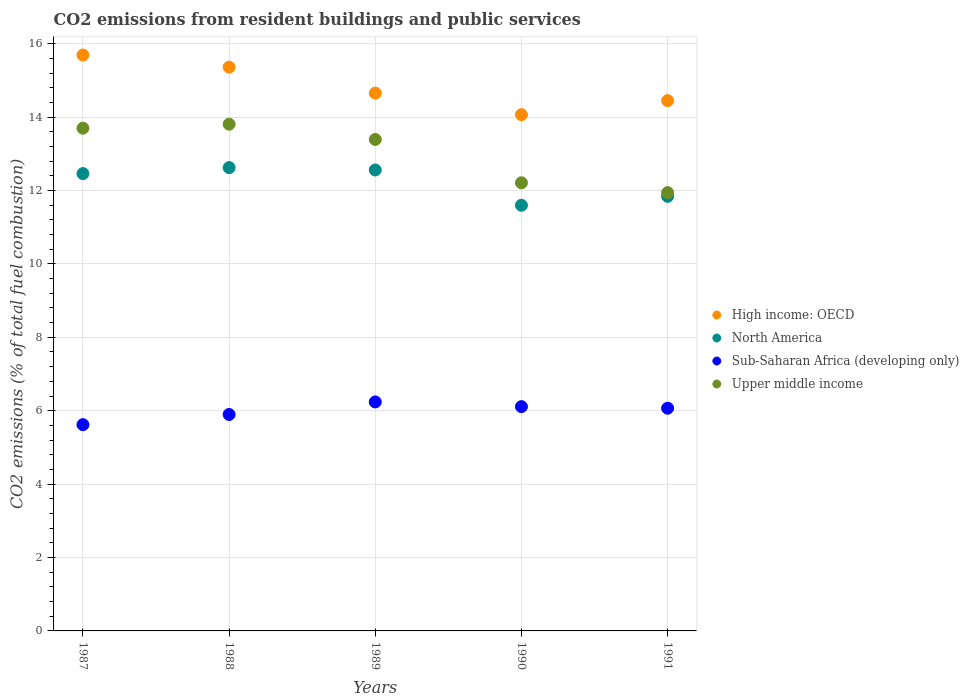What is the total CO2 emitted in North America in 1987?
Your answer should be very brief. 12.46. Across all years, what is the maximum total CO2 emitted in Sub-Saharan Africa (developing only)?
Your answer should be very brief. 6.24. Across all years, what is the minimum total CO2 emitted in High income: OECD?
Offer a very short reply. 14.06. What is the total total CO2 emitted in Sub-Saharan Africa (developing only) in the graph?
Make the answer very short. 29.93. What is the difference between the total CO2 emitted in North America in 1988 and that in 1989?
Keep it short and to the point. 0.06. What is the difference between the total CO2 emitted in Upper middle income in 1991 and the total CO2 emitted in High income: OECD in 1990?
Your answer should be compact. -2.12. What is the average total CO2 emitted in Upper middle income per year?
Give a very brief answer. 13.01. In the year 1991, what is the difference between the total CO2 emitted in Upper middle income and total CO2 emitted in North America?
Keep it short and to the point. 0.1. In how many years, is the total CO2 emitted in Sub-Saharan Africa (developing only) greater than 7.6?
Make the answer very short. 0. What is the ratio of the total CO2 emitted in High income: OECD in 1987 to that in 1988?
Make the answer very short. 1.02. Is the difference between the total CO2 emitted in Upper middle income in 1989 and 1991 greater than the difference between the total CO2 emitted in North America in 1989 and 1991?
Give a very brief answer. Yes. What is the difference between the highest and the second highest total CO2 emitted in North America?
Ensure brevity in your answer.  0.06. What is the difference between the highest and the lowest total CO2 emitted in High income: OECD?
Provide a short and direct response. 1.62. In how many years, is the total CO2 emitted in Sub-Saharan Africa (developing only) greater than the average total CO2 emitted in Sub-Saharan Africa (developing only) taken over all years?
Your answer should be very brief. 3. Is the sum of the total CO2 emitted in Upper middle income in 1988 and 1991 greater than the maximum total CO2 emitted in North America across all years?
Your answer should be compact. Yes. Is it the case that in every year, the sum of the total CO2 emitted in Sub-Saharan Africa (developing only) and total CO2 emitted in North America  is greater than the sum of total CO2 emitted in High income: OECD and total CO2 emitted in Upper middle income?
Keep it short and to the point. No. Is it the case that in every year, the sum of the total CO2 emitted in Upper middle income and total CO2 emitted in Sub-Saharan Africa (developing only)  is greater than the total CO2 emitted in North America?
Your response must be concise. Yes. Is the total CO2 emitted in Sub-Saharan Africa (developing only) strictly greater than the total CO2 emitted in High income: OECD over the years?
Keep it short and to the point. No. How many years are there in the graph?
Ensure brevity in your answer.  5. What is the difference between two consecutive major ticks on the Y-axis?
Offer a terse response. 2. Are the values on the major ticks of Y-axis written in scientific E-notation?
Your response must be concise. No. Does the graph contain grids?
Provide a succinct answer. Yes. Where does the legend appear in the graph?
Offer a very short reply. Center right. How many legend labels are there?
Ensure brevity in your answer.  4. How are the legend labels stacked?
Offer a terse response. Vertical. What is the title of the graph?
Offer a terse response. CO2 emissions from resident buildings and public services. Does "Paraguay" appear as one of the legend labels in the graph?
Your response must be concise. No. What is the label or title of the Y-axis?
Your answer should be compact. CO2 emissions (% of total fuel combustion). What is the CO2 emissions (% of total fuel combustion) in High income: OECD in 1987?
Provide a short and direct response. 15.69. What is the CO2 emissions (% of total fuel combustion) in North America in 1987?
Your response must be concise. 12.46. What is the CO2 emissions (% of total fuel combustion) of Sub-Saharan Africa (developing only) in 1987?
Make the answer very short. 5.62. What is the CO2 emissions (% of total fuel combustion) of Upper middle income in 1987?
Keep it short and to the point. 13.7. What is the CO2 emissions (% of total fuel combustion) in High income: OECD in 1988?
Offer a terse response. 15.36. What is the CO2 emissions (% of total fuel combustion) of North America in 1988?
Offer a terse response. 12.62. What is the CO2 emissions (% of total fuel combustion) in Sub-Saharan Africa (developing only) in 1988?
Keep it short and to the point. 5.9. What is the CO2 emissions (% of total fuel combustion) in Upper middle income in 1988?
Keep it short and to the point. 13.81. What is the CO2 emissions (% of total fuel combustion) in High income: OECD in 1989?
Provide a succinct answer. 14.65. What is the CO2 emissions (% of total fuel combustion) in North America in 1989?
Provide a succinct answer. 12.56. What is the CO2 emissions (% of total fuel combustion) in Sub-Saharan Africa (developing only) in 1989?
Make the answer very short. 6.24. What is the CO2 emissions (% of total fuel combustion) of Upper middle income in 1989?
Offer a terse response. 13.39. What is the CO2 emissions (% of total fuel combustion) in High income: OECD in 1990?
Provide a succinct answer. 14.06. What is the CO2 emissions (% of total fuel combustion) in North America in 1990?
Your response must be concise. 11.6. What is the CO2 emissions (% of total fuel combustion) in Sub-Saharan Africa (developing only) in 1990?
Offer a very short reply. 6.11. What is the CO2 emissions (% of total fuel combustion) in Upper middle income in 1990?
Your response must be concise. 12.21. What is the CO2 emissions (% of total fuel combustion) in High income: OECD in 1991?
Ensure brevity in your answer.  14.45. What is the CO2 emissions (% of total fuel combustion) of North America in 1991?
Provide a succinct answer. 11.84. What is the CO2 emissions (% of total fuel combustion) in Sub-Saharan Africa (developing only) in 1991?
Your answer should be compact. 6.07. What is the CO2 emissions (% of total fuel combustion) of Upper middle income in 1991?
Keep it short and to the point. 11.94. Across all years, what is the maximum CO2 emissions (% of total fuel combustion) of High income: OECD?
Offer a terse response. 15.69. Across all years, what is the maximum CO2 emissions (% of total fuel combustion) of North America?
Your response must be concise. 12.62. Across all years, what is the maximum CO2 emissions (% of total fuel combustion) of Sub-Saharan Africa (developing only)?
Offer a terse response. 6.24. Across all years, what is the maximum CO2 emissions (% of total fuel combustion) in Upper middle income?
Give a very brief answer. 13.81. Across all years, what is the minimum CO2 emissions (% of total fuel combustion) of High income: OECD?
Your answer should be compact. 14.06. Across all years, what is the minimum CO2 emissions (% of total fuel combustion) of North America?
Give a very brief answer. 11.6. Across all years, what is the minimum CO2 emissions (% of total fuel combustion) of Sub-Saharan Africa (developing only)?
Offer a very short reply. 5.62. Across all years, what is the minimum CO2 emissions (% of total fuel combustion) in Upper middle income?
Offer a very short reply. 11.94. What is the total CO2 emissions (% of total fuel combustion) in High income: OECD in the graph?
Keep it short and to the point. 74.22. What is the total CO2 emissions (% of total fuel combustion) of North America in the graph?
Give a very brief answer. 61.08. What is the total CO2 emissions (% of total fuel combustion) of Sub-Saharan Africa (developing only) in the graph?
Provide a short and direct response. 29.93. What is the total CO2 emissions (% of total fuel combustion) in Upper middle income in the graph?
Provide a succinct answer. 65.04. What is the difference between the CO2 emissions (% of total fuel combustion) of High income: OECD in 1987 and that in 1988?
Give a very brief answer. 0.33. What is the difference between the CO2 emissions (% of total fuel combustion) of North America in 1987 and that in 1988?
Make the answer very short. -0.16. What is the difference between the CO2 emissions (% of total fuel combustion) of Sub-Saharan Africa (developing only) in 1987 and that in 1988?
Give a very brief answer. -0.28. What is the difference between the CO2 emissions (% of total fuel combustion) in Upper middle income in 1987 and that in 1988?
Make the answer very short. -0.11. What is the difference between the CO2 emissions (% of total fuel combustion) in High income: OECD in 1987 and that in 1989?
Make the answer very short. 1.04. What is the difference between the CO2 emissions (% of total fuel combustion) in North America in 1987 and that in 1989?
Ensure brevity in your answer.  -0.1. What is the difference between the CO2 emissions (% of total fuel combustion) in Sub-Saharan Africa (developing only) in 1987 and that in 1989?
Ensure brevity in your answer.  -0.62. What is the difference between the CO2 emissions (% of total fuel combustion) of Upper middle income in 1987 and that in 1989?
Ensure brevity in your answer.  0.31. What is the difference between the CO2 emissions (% of total fuel combustion) in High income: OECD in 1987 and that in 1990?
Provide a succinct answer. 1.62. What is the difference between the CO2 emissions (% of total fuel combustion) in North America in 1987 and that in 1990?
Provide a short and direct response. 0.86. What is the difference between the CO2 emissions (% of total fuel combustion) of Sub-Saharan Africa (developing only) in 1987 and that in 1990?
Keep it short and to the point. -0.49. What is the difference between the CO2 emissions (% of total fuel combustion) of Upper middle income in 1987 and that in 1990?
Give a very brief answer. 1.49. What is the difference between the CO2 emissions (% of total fuel combustion) of High income: OECD in 1987 and that in 1991?
Offer a terse response. 1.24. What is the difference between the CO2 emissions (% of total fuel combustion) of North America in 1987 and that in 1991?
Your answer should be very brief. 0.62. What is the difference between the CO2 emissions (% of total fuel combustion) of Sub-Saharan Africa (developing only) in 1987 and that in 1991?
Make the answer very short. -0.45. What is the difference between the CO2 emissions (% of total fuel combustion) of Upper middle income in 1987 and that in 1991?
Ensure brevity in your answer.  1.76. What is the difference between the CO2 emissions (% of total fuel combustion) of High income: OECD in 1988 and that in 1989?
Your response must be concise. 0.71. What is the difference between the CO2 emissions (% of total fuel combustion) in North America in 1988 and that in 1989?
Offer a terse response. 0.06. What is the difference between the CO2 emissions (% of total fuel combustion) in Sub-Saharan Africa (developing only) in 1988 and that in 1989?
Offer a very short reply. -0.34. What is the difference between the CO2 emissions (% of total fuel combustion) in Upper middle income in 1988 and that in 1989?
Offer a terse response. 0.42. What is the difference between the CO2 emissions (% of total fuel combustion) in High income: OECD in 1988 and that in 1990?
Offer a terse response. 1.3. What is the difference between the CO2 emissions (% of total fuel combustion) in North America in 1988 and that in 1990?
Offer a very short reply. 1.03. What is the difference between the CO2 emissions (% of total fuel combustion) of Sub-Saharan Africa (developing only) in 1988 and that in 1990?
Your answer should be compact. -0.21. What is the difference between the CO2 emissions (% of total fuel combustion) in Upper middle income in 1988 and that in 1990?
Provide a succinct answer. 1.6. What is the difference between the CO2 emissions (% of total fuel combustion) in High income: OECD in 1988 and that in 1991?
Offer a terse response. 0.91. What is the difference between the CO2 emissions (% of total fuel combustion) of North America in 1988 and that in 1991?
Ensure brevity in your answer.  0.78. What is the difference between the CO2 emissions (% of total fuel combustion) in Sub-Saharan Africa (developing only) in 1988 and that in 1991?
Offer a very short reply. -0.17. What is the difference between the CO2 emissions (% of total fuel combustion) of Upper middle income in 1988 and that in 1991?
Provide a short and direct response. 1.86. What is the difference between the CO2 emissions (% of total fuel combustion) in High income: OECD in 1989 and that in 1990?
Ensure brevity in your answer.  0.59. What is the difference between the CO2 emissions (% of total fuel combustion) of North America in 1989 and that in 1990?
Provide a short and direct response. 0.96. What is the difference between the CO2 emissions (% of total fuel combustion) in Sub-Saharan Africa (developing only) in 1989 and that in 1990?
Keep it short and to the point. 0.13. What is the difference between the CO2 emissions (% of total fuel combustion) of Upper middle income in 1989 and that in 1990?
Provide a short and direct response. 1.18. What is the difference between the CO2 emissions (% of total fuel combustion) in High income: OECD in 1989 and that in 1991?
Your response must be concise. 0.2. What is the difference between the CO2 emissions (% of total fuel combustion) of North America in 1989 and that in 1991?
Provide a succinct answer. 0.72. What is the difference between the CO2 emissions (% of total fuel combustion) in Sub-Saharan Africa (developing only) in 1989 and that in 1991?
Provide a short and direct response. 0.17. What is the difference between the CO2 emissions (% of total fuel combustion) in Upper middle income in 1989 and that in 1991?
Your answer should be compact. 1.45. What is the difference between the CO2 emissions (% of total fuel combustion) in High income: OECD in 1990 and that in 1991?
Make the answer very short. -0.38. What is the difference between the CO2 emissions (% of total fuel combustion) of North America in 1990 and that in 1991?
Keep it short and to the point. -0.24. What is the difference between the CO2 emissions (% of total fuel combustion) in Sub-Saharan Africa (developing only) in 1990 and that in 1991?
Offer a terse response. 0.04. What is the difference between the CO2 emissions (% of total fuel combustion) in Upper middle income in 1990 and that in 1991?
Your answer should be compact. 0.27. What is the difference between the CO2 emissions (% of total fuel combustion) in High income: OECD in 1987 and the CO2 emissions (% of total fuel combustion) in North America in 1988?
Your answer should be compact. 3.07. What is the difference between the CO2 emissions (% of total fuel combustion) in High income: OECD in 1987 and the CO2 emissions (% of total fuel combustion) in Sub-Saharan Africa (developing only) in 1988?
Make the answer very short. 9.79. What is the difference between the CO2 emissions (% of total fuel combustion) of High income: OECD in 1987 and the CO2 emissions (% of total fuel combustion) of Upper middle income in 1988?
Your answer should be very brief. 1.88. What is the difference between the CO2 emissions (% of total fuel combustion) of North America in 1987 and the CO2 emissions (% of total fuel combustion) of Sub-Saharan Africa (developing only) in 1988?
Provide a succinct answer. 6.56. What is the difference between the CO2 emissions (% of total fuel combustion) in North America in 1987 and the CO2 emissions (% of total fuel combustion) in Upper middle income in 1988?
Offer a terse response. -1.35. What is the difference between the CO2 emissions (% of total fuel combustion) in Sub-Saharan Africa (developing only) in 1987 and the CO2 emissions (% of total fuel combustion) in Upper middle income in 1988?
Provide a short and direct response. -8.19. What is the difference between the CO2 emissions (% of total fuel combustion) in High income: OECD in 1987 and the CO2 emissions (% of total fuel combustion) in North America in 1989?
Make the answer very short. 3.13. What is the difference between the CO2 emissions (% of total fuel combustion) of High income: OECD in 1987 and the CO2 emissions (% of total fuel combustion) of Sub-Saharan Africa (developing only) in 1989?
Provide a succinct answer. 9.45. What is the difference between the CO2 emissions (% of total fuel combustion) in High income: OECD in 1987 and the CO2 emissions (% of total fuel combustion) in Upper middle income in 1989?
Keep it short and to the point. 2.3. What is the difference between the CO2 emissions (% of total fuel combustion) in North America in 1987 and the CO2 emissions (% of total fuel combustion) in Sub-Saharan Africa (developing only) in 1989?
Give a very brief answer. 6.22. What is the difference between the CO2 emissions (% of total fuel combustion) in North America in 1987 and the CO2 emissions (% of total fuel combustion) in Upper middle income in 1989?
Your response must be concise. -0.93. What is the difference between the CO2 emissions (% of total fuel combustion) in Sub-Saharan Africa (developing only) in 1987 and the CO2 emissions (% of total fuel combustion) in Upper middle income in 1989?
Give a very brief answer. -7.77. What is the difference between the CO2 emissions (% of total fuel combustion) of High income: OECD in 1987 and the CO2 emissions (% of total fuel combustion) of North America in 1990?
Make the answer very short. 4.09. What is the difference between the CO2 emissions (% of total fuel combustion) of High income: OECD in 1987 and the CO2 emissions (% of total fuel combustion) of Sub-Saharan Africa (developing only) in 1990?
Ensure brevity in your answer.  9.58. What is the difference between the CO2 emissions (% of total fuel combustion) of High income: OECD in 1987 and the CO2 emissions (% of total fuel combustion) of Upper middle income in 1990?
Make the answer very short. 3.48. What is the difference between the CO2 emissions (% of total fuel combustion) of North America in 1987 and the CO2 emissions (% of total fuel combustion) of Sub-Saharan Africa (developing only) in 1990?
Your answer should be very brief. 6.35. What is the difference between the CO2 emissions (% of total fuel combustion) in North America in 1987 and the CO2 emissions (% of total fuel combustion) in Upper middle income in 1990?
Offer a terse response. 0.25. What is the difference between the CO2 emissions (% of total fuel combustion) of Sub-Saharan Africa (developing only) in 1987 and the CO2 emissions (% of total fuel combustion) of Upper middle income in 1990?
Offer a very short reply. -6.59. What is the difference between the CO2 emissions (% of total fuel combustion) in High income: OECD in 1987 and the CO2 emissions (% of total fuel combustion) in North America in 1991?
Provide a succinct answer. 3.85. What is the difference between the CO2 emissions (% of total fuel combustion) in High income: OECD in 1987 and the CO2 emissions (% of total fuel combustion) in Sub-Saharan Africa (developing only) in 1991?
Offer a terse response. 9.62. What is the difference between the CO2 emissions (% of total fuel combustion) in High income: OECD in 1987 and the CO2 emissions (% of total fuel combustion) in Upper middle income in 1991?
Ensure brevity in your answer.  3.75. What is the difference between the CO2 emissions (% of total fuel combustion) in North America in 1987 and the CO2 emissions (% of total fuel combustion) in Sub-Saharan Africa (developing only) in 1991?
Offer a terse response. 6.39. What is the difference between the CO2 emissions (% of total fuel combustion) of North America in 1987 and the CO2 emissions (% of total fuel combustion) of Upper middle income in 1991?
Provide a short and direct response. 0.52. What is the difference between the CO2 emissions (% of total fuel combustion) of Sub-Saharan Africa (developing only) in 1987 and the CO2 emissions (% of total fuel combustion) of Upper middle income in 1991?
Provide a short and direct response. -6.32. What is the difference between the CO2 emissions (% of total fuel combustion) of High income: OECD in 1988 and the CO2 emissions (% of total fuel combustion) of North America in 1989?
Provide a succinct answer. 2.8. What is the difference between the CO2 emissions (% of total fuel combustion) in High income: OECD in 1988 and the CO2 emissions (% of total fuel combustion) in Sub-Saharan Africa (developing only) in 1989?
Your answer should be compact. 9.12. What is the difference between the CO2 emissions (% of total fuel combustion) of High income: OECD in 1988 and the CO2 emissions (% of total fuel combustion) of Upper middle income in 1989?
Give a very brief answer. 1.97. What is the difference between the CO2 emissions (% of total fuel combustion) in North America in 1988 and the CO2 emissions (% of total fuel combustion) in Sub-Saharan Africa (developing only) in 1989?
Offer a very short reply. 6.38. What is the difference between the CO2 emissions (% of total fuel combustion) in North America in 1988 and the CO2 emissions (% of total fuel combustion) in Upper middle income in 1989?
Keep it short and to the point. -0.77. What is the difference between the CO2 emissions (% of total fuel combustion) in Sub-Saharan Africa (developing only) in 1988 and the CO2 emissions (% of total fuel combustion) in Upper middle income in 1989?
Offer a terse response. -7.49. What is the difference between the CO2 emissions (% of total fuel combustion) of High income: OECD in 1988 and the CO2 emissions (% of total fuel combustion) of North America in 1990?
Offer a terse response. 3.76. What is the difference between the CO2 emissions (% of total fuel combustion) of High income: OECD in 1988 and the CO2 emissions (% of total fuel combustion) of Sub-Saharan Africa (developing only) in 1990?
Your response must be concise. 9.25. What is the difference between the CO2 emissions (% of total fuel combustion) of High income: OECD in 1988 and the CO2 emissions (% of total fuel combustion) of Upper middle income in 1990?
Make the answer very short. 3.15. What is the difference between the CO2 emissions (% of total fuel combustion) in North America in 1988 and the CO2 emissions (% of total fuel combustion) in Sub-Saharan Africa (developing only) in 1990?
Your response must be concise. 6.51. What is the difference between the CO2 emissions (% of total fuel combustion) in North America in 1988 and the CO2 emissions (% of total fuel combustion) in Upper middle income in 1990?
Your answer should be very brief. 0.41. What is the difference between the CO2 emissions (% of total fuel combustion) in Sub-Saharan Africa (developing only) in 1988 and the CO2 emissions (% of total fuel combustion) in Upper middle income in 1990?
Keep it short and to the point. -6.31. What is the difference between the CO2 emissions (% of total fuel combustion) in High income: OECD in 1988 and the CO2 emissions (% of total fuel combustion) in North America in 1991?
Offer a terse response. 3.52. What is the difference between the CO2 emissions (% of total fuel combustion) of High income: OECD in 1988 and the CO2 emissions (% of total fuel combustion) of Sub-Saharan Africa (developing only) in 1991?
Give a very brief answer. 9.29. What is the difference between the CO2 emissions (% of total fuel combustion) in High income: OECD in 1988 and the CO2 emissions (% of total fuel combustion) in Upper middle income in 1991?
Offer a very short reply. 3.42. What is the difference between the CO2 emissions (% of total fuel combustion) in North America in 1988 and the CO2 emissions (% of total fuel combustion) in Sub-Saharan Africa (developing only) in 1991?
Provide a short and direct response. 6.56. What is the difference between the CO2 emissions (% of total fuel combustion) in North America in 1988 and the CO2 emissions (% of total fuel combustion) in Upper middle income in 1991?
Your answer should be very brief. 0.68. What is the difference between the CO2 emissions (% of total fuel combustion) of Sub-Saharan Africa (developing only) in 1988 and the CO2 emissions (% of total fuel combustion) of Upper middle income in 1991?
Offer a terse response. -6.04. What is the difference between the CO2 emissions (% of total fuel combustion) in High income: OECD in 1989 and the CO2 emissions (% of total fuel combustion) in North America in 1990?
Make the answer very short. 3.06. What is the difference between the CO2 emissions (% of total fuel combustion) of High income: OECD in 1989 and the CO2 emissions (% of total fuel combustion) of Sub-Saharan Africa (developing only) in 1990?
Provide a succinct answer. 8.54. What is the difference between the CO2 emissions (% of total fuel combustion) of High income: OECD in 1989 and the CO2 emissions (% of total fuel combustion) of Upper middle income in 1990?
Ensure brevity in your answer.  2.44. What is the difference between the CO2 emissions (% of total fuel combustion) of North America in 1989 and the CO2 emissions (% of total fuel combustion) of Sub-Saharan Africa (developing only) in 1990?
Your answer should be very brief. 6.45. What is the difference between the CO2 emissions (% of total fuel combustion) in North America in 1989 and the CO2 emissions (% of total fuel combustion) in Upper middle income in 1990?
Keep it short and to the point. 0.35. What is the difference between the CO2 emissions (% of total fuel combustion) in Sub-Saharan Africa (developing only) in 1989 and the CO2 emissions (% of total fuel combustion) in Upper middle income in 1990?
Your response must be concise. -5.97. What is the difference between the CO2 emissions (% of total fuel combustion) in High income: OECD in 1989 and the CO2 emissions (% of total fuel combustion) in North America in 1991?
Keep it short and to the point. 2.81. What is the difference between the CO2 emissions (% of total fuel combustion) in High income: OECD in 1989 and the CO2 emissions (% of total fuel combustion) in Sub-Saharan Africa (developing only) in 1991?
Your answer should be very brief. 8.59. What is the difference between the CO2 emissions (% of total fuel combustion) of High income: OECD in 1989 and the CO2 emissions (% of total fuel combustion) of Upper middle income in 1991?
Provide a short and direct response. 2.71. What is the difference between the CO2 emissions (% of total fuel combustion) in North America in 1989 and the CO2 emissions (% of total fuel combustion) in Sub-Saharan Africa (developing only) in 1991?
Offer a terse response. 6.49. What is the difference between the CO2 emissions (% of total fuel combustion) in North America in 1989 and the CO2 emissions (% of total fuel combustion) in Upper middle income in 1991?
Your response must be concise. 0.62. What is the difference between the CO2 emissions (% of total fuel combustion) in Sub-Saharan Africa (developing only) in 1989 and the CO2 emissions (% of total fuel combustion) in Upper middle income in 1991?
Your answer should be compact. -5.7. What is the difference between the CO2 emissions (% of total fuel combustion) of High income: OECD in 1990 and the CO2 emissions (% of total fuel combustion) of North America in 1991?
Keep it short and to the point. 2.22. What is the difference between the CO2 emissions (% of total fuel combustion) in High income: OECD in 1990 and the CO2 emissions (% of total fuel combustion) in Sub-Saharan Africa (developing only) in 1991?
Make the answer very short. 8. What is the difference between the CO2 emissions (% of total fuel combustion) of High income: OECD in 1990 and the CO2 emissions (% of total fuel combustion) of Upper middle income in 1991?
Offer a terse response. 2.12. What is the difference between the CO2 emissions (% of total fuel combustion) in North America in 1990 and the CO2 emissions (% of total fuel combustion) in Sub-Saharan Africa (developing only) in 1991?
Your answer should be compact. 5.53. What is the difference between the CO2 emissions (% of total fuel combustion) in North America in 1990 and the CO2 emissions (% of total fuel combustion) in Upper middle income in 1991?
Ensure brevity in your answer.  -0.34. What is the difference between the CO2 emissions (% of total fuel combustion) of Sub-Saharan Africa (developing only) in 1990 and the CO2 emissions (% of total fuel combustion) of Upper middle income in 1991?
Make the answer very short. -5.83. What is the average CO2 emissions (% of total fuel combustion) in High income: OECD per year?
Your response must be concise. 14.84. What is the average CO2 emissions (% of total fuel combustion) in North America per year?
Give a very brief answer. 12.22. What is the average CO2 emissions (% of total fuel combustion) of Sub-Saharan Africa (developing only) per year?
Your answer should be compact. 5.99. What is the average CO2 emissions (% of total fuel combustion) of Upper middle income per year?
Ensure brevity in your answer.  13.01. In the year 1987, what is the difference between the CO2 emissions (% of total fuel combustion) in High income: OECD and CO2 emissions (% of total fuel combustion) in North America?
Provide a succinct answer. 3.23. In the year 1987, what is the difference between the CO2 emissions (% of total fuel combustion) in High income: OECD and CO2 emissions (% of total fuel combustion) in Sub-Saharan Africa (developing only)?
Make the answer very short. 10.07. In the year 1987, what is the difference between the CO2 emissions (% of total fuel combustion) in High income: OECD and CO2 emissions (% of total fuel combustion) in Upper middle income?
Keep it short and to the point. 1.99. In the year 1987, what is the difference between the CO2 emissions (% of total fuel combustion) of North America and CO2 emissions (% of total fuel combustion) of Sub-Saharan Africa (developing only)?
Provide a succinct answer. 6.84. In the year 1987, what is the difference between the CO2 emissions (% of total fuel combustion) of North America and CO2 emissions (% of total fuel combustion) of Upper middle income?
Provide a succinct answer. -1.24. In the year 1987, what is the difference between the CO2 emissions (% of total fuel combustion) of Sub-Saharan Africa (developing only) and CO2 emissions (% of total fuel combustion) of Upper middle income?
Provide a succinct answer. -8.08. In the year 1988, what is the difference between the CO2 emissions (% of total fuel combustion) of High income: OECD and CO2 emissions (% of total fuel combustion) of North America?
Your response must be concise. 2.74. In the year 1988, what is the difference between the CO2 emissions (% of total fuel combustion) of High income: OECD and CO2 emissions (% of total fuel combustion) of Sub-Saharan Africa (developing only)?
Keep it short and to the point. 9.46. In the year 1988, what is the difference between the CO2 emissions (% of total fuel combustion) of High income: OECD and CO2 emissions (% of total fuel combustion) of Upper middle income?
Your response must be concise. 1.55. In the year 1988, what is the difference between the CO2 emissions (% of total fuel combustion) of North America and CO2 emissions (% of total fuel combustion) of Sub-Saharan Africa (developing only)?
Give a very brief answer. 6.73. In the year 1988, what is the difference between the CO2 emissions (% of total fuel combustion) of North America and CO2 emissions (% of total fuel combustion) of Upper middle income?
Provide a succinct answer. -1.18. In the year 1988, what is the difference between the CO2 emissions (% of total fuel combustion) of Sub-Saharan Africa (developing only) and CO2 emissions (% of total fuel combustion) of Upper middle income?
Offer a very short reply. -7.91. In the year 1989, what is the difference between the CO2 emissions (% of total fuel combustion) of High income: OECD and CO2 emissions (% of total fuel combustion) of North America?
Keep it short and to the point. 2.09. In the year 1989, what is the difference between the CO2 emissions (% of total fuel combustion) in High income: OECD and CO2 emissions (% of total fuel combustion) in Sub-Saharan Africa (developing only)?
Keep it short and to the point. 8.41. In the year 1989, what is the difference between the CO2 emissions (% of total fuel combustion) of High income: OECD and CO2 emissions (% of total fuel combustion) of Upper middle income?
Ensure brevity in your answer.  1.26. In the year 1989, what is the difference between the CO2 emissions (% of total fuel combustion) of North America and CO2 emissions (% of total fuel combustion) of Sub-Saharan Africa (developing only)?
Make the answer very short. 6.32. In the year 1989, what is the difference between the CO2 emissions (% of total fuel combustion) of North America and CO2 emissions (% of total fuel combustion) of Upper middle income?
Ensure brevity in your answer.  -0.83. In the year 1989, what is the difference between the CO2 emissions (% of total fuel combustion) of Sub-Saharan Africa (developing only) and CO2 emissions (% of total fuel combustion) of Upper middle income?
Provide a short and direct response. -7.15. In the year 1990, what is the difference between the CO2 emissions (% of total fuel combustion) in High income: OECD and CO2 emissions (% of total fuel combustion) in North America?
Provide a succinct answer. 2.47. In the year 1990, what is the difference between the CO2 emissions (% of total fuel combustion) in High income: OECD and CO2 emissions (% of total fuel combustion) in Sub-Saharan Africa (developing only)?
Provide a succinct answer. 7.95. In the year 1990, what is the difference between the CO2 emissions (% of total fuel combustion) of High income: OECD and CO2 emissions (% of total fuel combustion) of Upper middle income?
Provide a succinct answer. 1.86. In the year 1990, what is the difference between the CO2 emissions (% of total fuel combustion) of North America and CO2 emissions (% of total fuel combustion) of Sub-Saharan Africa (developing only)?
Provide a succinct answer. 5.49. In the year 1990, what is the difference between the CO2 emissions (% of total fuel combustion) in North America and CO2 emissions (% of total fuel combustion) in Upper middle income?
Ensure brevity in your answer.  -0.61. In the year 1990, what is the difference between the CO2 emissions (% of total fuel combustion) in Sub-Saharan Africa (developing only) and CO2 emissions (% of total fuel combustion) in Upper middle income?
Keep it short and to the point. -6.1. In the year 1991, what is the difference between the CO2 emissions (% of total fuel combustion) of High income: OECD and CO2 emissions (% of total fuel combustion) of North America?
Your answer should be very brief. 2.61. In the year 1991, what is the difference between the CO2 emissions (% of total fuel combustion) in High income: OECD and CO2 emissions (% of total fuel combustion) in Sub-Saharan Africa (developing only)?
Keep it short and to the point. 8.38. In the year 1991, what is the difference between the CO2 emissions (% of total fuel combustion) of High income: OECD and CO2 emissions (% of total fuel combustion) of Upper middle income?
Provide a succinct answer. 2.51. In the year 1991, what is the difference between the CO2 emissions (% of total fuel combustion) of North America and CO2 emissions (% of total fuel combustion) of Sub-Saharan Africa (developing only)?
Give a very brief answer. 5.77. In the year 1991, what is the difference between the CO2 emissions (% of total fuel combustion) of North America and CO2 emissions (% of total fuel combustion) of Upper middle income?
Provide a succinct answer. -0.1. In the year 1991, what is the difference between the CO2 emissions (% of total fuel combustion) in Sub-Saharan Africa (developing only) and CO2 emissions (% of total fuel combustion) in Upper middle income?
Make the answer very short. -5.87. What is the ratio of the CO2 emissions (% of total fuel combustion) of High income: OECD in 1987 to that in 1988?
Offer a terse response. 1.02. What is the ratio of the CO2 emissions (% of total fuel combustion) in North America in 1987 to that in 1988?
Keep it short and to the point. 0.99. What is the ratio of the CO2 emissions (% of total fuel combustion) in Sub-Saharan Africa (developing only) in 1987 to that in 1988?
Your answer should be very brief. 0.95. What is the ratio of the CO2 emissions (% of total fuel combustion) of High income: OECD in 1987 to that in 1989?
Ensure brevity in your answer.  1.07. What is the ratio of the CO2 emissions (% of total fuel combustion) of Sub-Saharan Africa (developing only) in 1987 to that in 1989?
Your answer should be compact. 0.9. What is the ratio of the CO2 emissions (% of total fuel combustion) of Upper middle income in 1987 to that in 1989?
Your answer should be compact. 1.02. What is the ratio of the CO2 emissions (% of total fuel combustion) of High income: OECD in 1987 to that in 1990?
Keep it short and to the point. 1.12. What is the ratio of the CO2 emissions (% of total fuel combustion) of North America in 1987 to that in 1990?
Keep it short and to the point. 1.07. What is the ratio of the CO2 emissions (% of total fuel combustion) of Sub-Saharan Africa (developing only) in 1987 to that in 1990?
Give a very brief answer. 0.92. What is the ratio of the CO2 emissions (% of total fuel combustion) of Upper middle income in 1987 to that in 1990?
Give a very brief answer. 1.12. What is the ratio of the CO2 emissions (% of total fuel combustion) of High income: OECD in 1987 to that in 1991?
Offer a terse response. 1.09. What is the ratio of the CO2 emissions (% of total fuel combustion) in North America in 1987 to that in 1991?
Your answer should be compact. 1.05. What is the ratio of the CO2 emissions (% of total fuel combustion) of Sub-Saharan Africa (developing only) in 1987 to that in 1991?
Provide a short and direct response. 0.93. What is the ratio of the CO2 emissions (% of total fuel combustion) in Upper middle income in 1987 to that in 1991?
Make the answer very short. 1.15. What is the ratio of the CO2 emissions (% of total fuel combustion) of High income: OECD in 1988 to that in 1989?
Keep it short and to the point. 1.05. What is the ratio of the CO2 emissions (% of total fuel combustion) of Sub-Saharan Africa (developing only) in 1988 to that in 1989?
Give a very brief answer. 0.95. What is the ratio of the CO2 emissions (% of total fuel combustion) in Upper middle income in 1988 to that in 1989?
Ensure brevity in your answer.  1.03. What is the ratio of the CO2 emissions (% of total fuel combustion) in High income: OECD in 1988 to that in 1990?
Offer a terse response. 1.09. What is the ratio of the CO2 emissions (% of total fuel combustion) in North America in 1988 to that in 1990?
Your answer should be compact. 1.09. What is the ratio of the CO2 emissions (% of total fuel combustion) of Sub-Saharan Africa (developing only) in 1988 to that in 1990?
Give a very brief answer. 0.96. What is the ratio of the CO2 emissions (% of total fuel combustion) of Upper middle income in 1988 to that in 1990?
Give a very brief answer. 1.13. What is the ratio of the CO2 emissions (% of total fuel combustion) of High income: OECD in 1988 to that in 1991?
Provide a short and direct response. 1.06. What is the ratio of the CO2 emissions (% of total fuel combustion) of North America in 1988 to that in 1991?
Give a very brief answer. 1.07. What is the ratio of the CO2 emissions (% of total fuel combustion) of Sub-Saharan Africa (developing only) in 1988 to that in 1991?
Provide a succinct answer. 0.97. What is the ratio of the CO2 emissions (% of total fuel combustion) of Upper middle income in 1988 to that in 1991?
Offer a very short reply. 1.16. What is the ratio of the CO2 emissions (% of total fuel combustion) in High income: OECD in 1989 to that in 1990?
Your answer should be compact. 1.04. What is the ratio of the CO2 emissions (% of total fuel combustion) in North America in 1989 to that in 1990?
Offer a very short reply. 1.08. What is the ratio of the CO2 emissions (% of total fuel combustion) in Sub-Saharan Africa (developing only) in 1989 to that in 1990?
Your response must be concise. 1.02. What is the ratio of the CO2 emissions (% of total fuel combustion) of Upper middle income in 1989 to that in 1990?
Your answer should be very brief. 1.1. What is the ratio of the CO2 emissions (% of total fuel combustion) of High income: OECD in 1989 to that in 1991?
Ensure brevity in your answer.  1.01. What is the ratio of the CO2 emissions (% of total fuel combustion) of North America in 1989 to that in 1991?
Your response must be concise. 1.06. What is the ratio of the CO2 emissions (% of total fuel combustion) in Sub-Saharan Africa (developing only) in 1989 to that in 1991?
Keep it short and to the point. 1.03. What is the ratio of the CO2 emissions (% of total fuel combustion) of Upper middle income in 1989 to that in 1991?
Ensure brevity in your answer.  1.12. What is the ratio of the CO2 emissions (% of total fuel combustion) in High income: OECD in 1990 to that in 1991?
Give a very brief answer. 0.97. What is the ratio of the CO2 emissions (% of total fuel combustion) of North America in 1990 to that in 1991?
Ensure brevity in your answer.  0.98. What is the ratio of the CO2 emissions (% of total fuel combustion) in Sub-Saharan Africa (developing only) in 1990 to that in 1991?
Offer a terse response. 1.01. What is the ratio of the CO2 emissions (% of total fuel combustion) of Upper middle income in 1990 to that in 1991?
Keep it short and to the point. 1.02. What is the difference between the highest and the second highest CO2 emissions (% of total fuel combustion) in High income: OECD?
Offer a terse response. 0.33. What is the difference between the highest and the second highest CO2 emissions (% of total fuel combustion) in North America?
Ensure brevity in your answer.  0.06. What is the difference between the highest and the second highest CO2 emissions (% of total fuel combustion) in Sub-Saharan Africa (developing only)?
Your answer should be very brief. 0.13. What is the difference between the highest and the second highest CO2 emissions (% of total fuel combustion) of Upper middle income?
Keep it short and to the point. 0.11. What is the difference between the highest and the lowest CO2 emissions (% of total fuel combustion) of High income: OECD?
Your answer should be very brief. 1.62. What is the difference between the highest and the lowest CO2 emissions (% of total fuel combustion) in North America?
Your answer should be very brief. 1.03. What is the difference between the highest and the lowest CO2 emissions (% of total fuel combustion) in Sub-Saharan Africa (developing only)?
Your response must be concise. 0.62. What is the difference between the highest and the lowest CO2 emissions (% of total fuel combustion) of Upper middle income?
Keep it short and to the point. 1.86. 